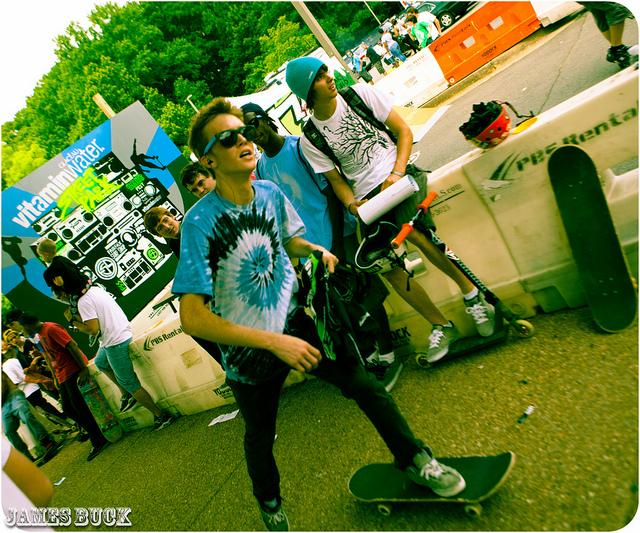What type of event is happening here? Please explain your reasoning. skateboard expo. A crowd of people are gathered and several people with skateboards are present. 